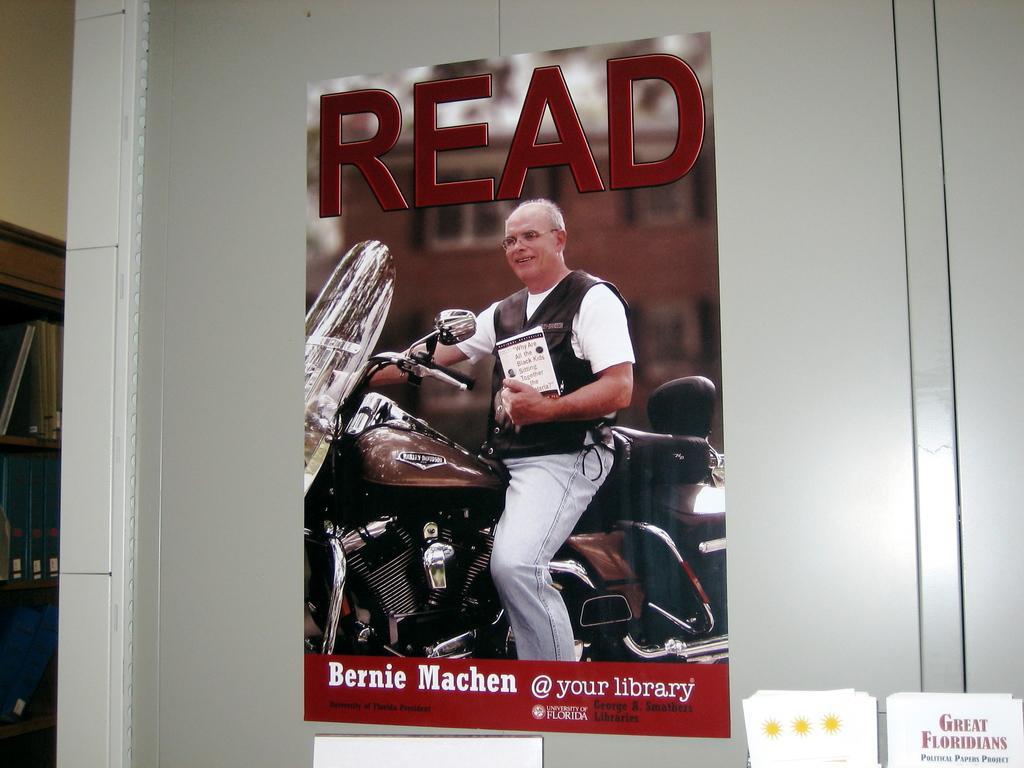In one or two sentences, can you explain what this image depicts? In this picture a poster is highlighted with "RED" title. Here we can see one man sittting on a bike and holding a book in his hand. At the left side of the picture we can see a rack where books are arranged. 